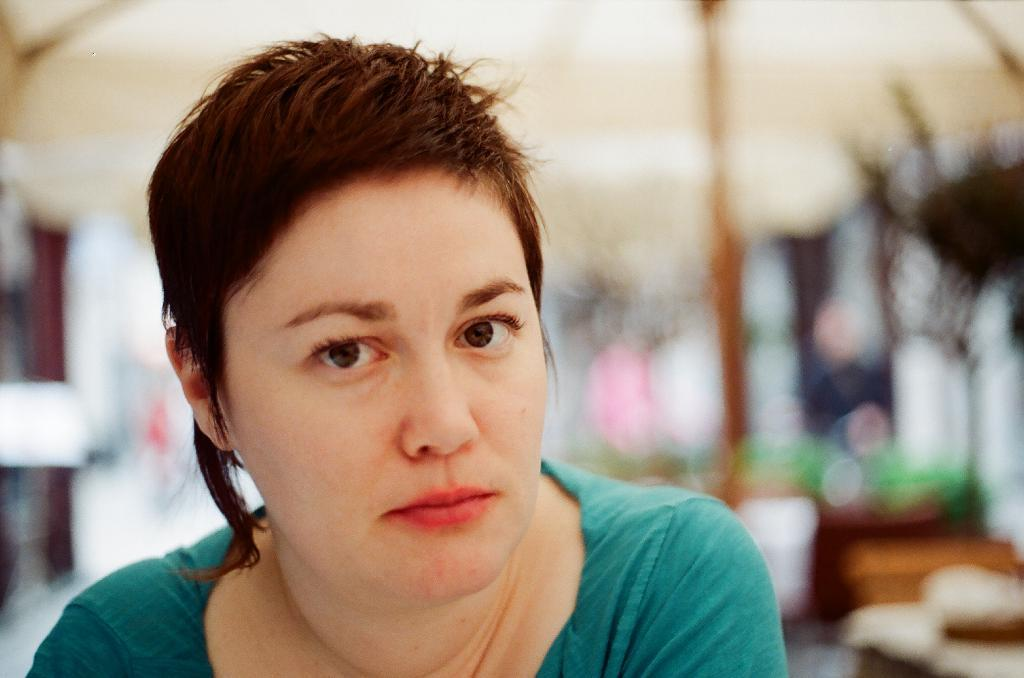What is the main subject of the image? There is a person's face in the front of the image. Can you describe the background of the image? The background of the image is blurred. What type of tent can be seen in the background of the image? There is no tent present in the image; the background is blurred. What color is the pickle that the person is holding in the image? There is no pickle present in the image; it only shows a person's face. 